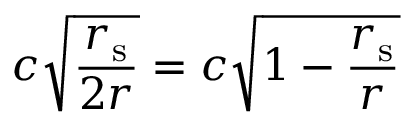<formula> <loc_0><loc_0><loc_500><loc_500>c { \sqrt { \frac { r _ { s } } { 2 r } } } = c { \sqrt { 1 - { \frac { r _ { s } } { r } } } }</formula> 